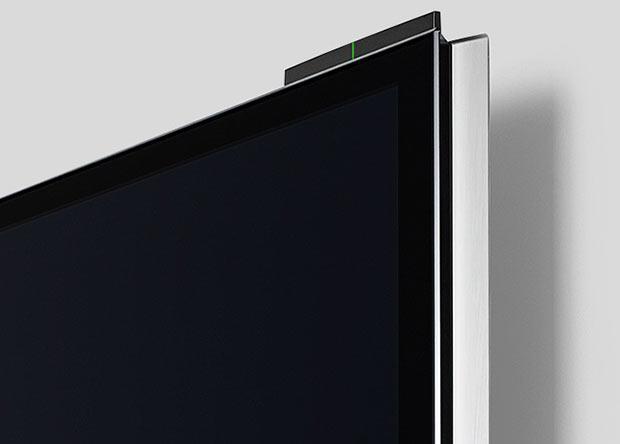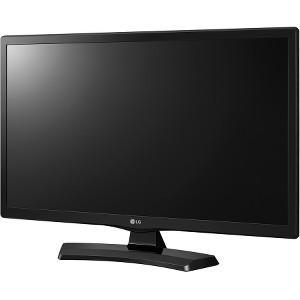The first image is the image on the left, the second image is the image on the right. Examine the images to the left and right. Is the description "Each image contains a rectangular gray-black screen that is displayed head-on instead of at an angle." accurate? Answer yes or no. No. The first image is the image on the left, the second image is the image on the right. Given the left and right images, does the statement "One picture shows a TV above a piece of furniture." hold true? Answer yes or no. No. 